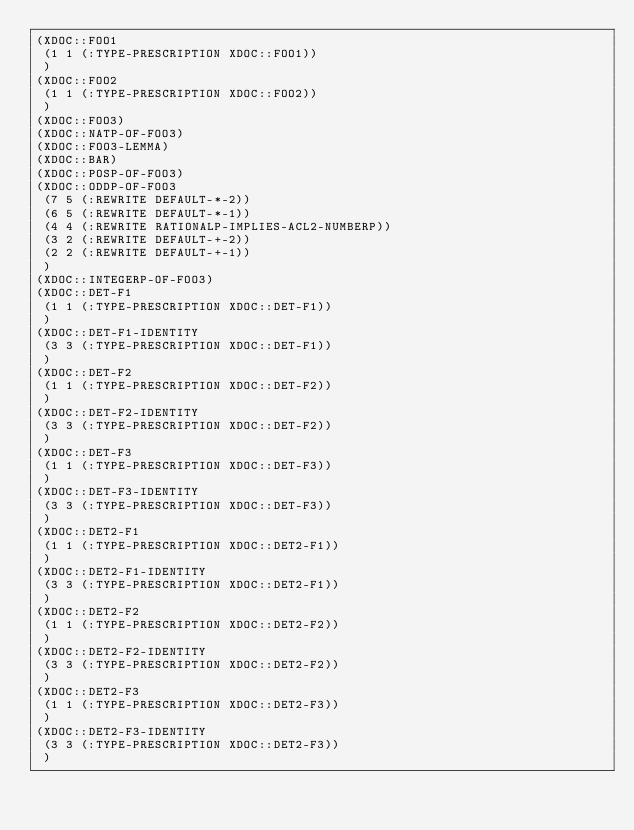<code> <loc_0><loc_0><loc_500><loc_500><_Lisp_>(XDOC::FOO1
 (1 1 (:TYPE-PRESCRIPTION XDOC::FOO1))
 )
(XDOC::FOO2
 (1 1 (:TYPE-PRESCRIPTION XDOC::FOO2))
 )
(XDOC::FOO3)
(XDOC::NATP-OF-FOO3)
(XDOC::FOO3-LEMMA)
(XDOC::BAR)
(XDOC::POSP-OF-FOO3)
(XDOC::ODDP-OF-FOO3
 (7 5 (:REWRITE DEFAULT-*-2))
 (6 5 (:REWRITE DEFAULT-*-1))
 (4 4 (:REWRITE RATIONALP-IMPLIES-ACL2-NUMBERP))
 (3 2 (:REWRITE DEFAULT-+-2))
 (2 2 (:REWRITE DEFAULT-+-1))
 )
(XDOC::INTEGERP-OF-FOO3)
(XDOC::DET-F1
 (1 1 (:TYPE-PRESCRIPTION XDOC::DET-F1))
 )
(XDOC::DET-F1-IDENTITY
 (3 3 (:TYPE-PRESCRIPTION XDOC::DET-F1))
 )
(XDOC::DET-F2
 (1 1 (:TYPE-PRESCRIPTION XDOC::DET-F2))
 )
(XDOC::DET-F2-IDENTITY
 (3 3 (:TYPE-PRESCRIPTION XDOC::DET-F2))
 )
(XDOC::DET-F3
 (1 1 (:TYPE-PRESCRIPTION XDOC::DET-F3))
 )
(XDOC::DET-F3-IDENTITY
 (3 3 (:TYPE-PRESCRIPTION XDOC::DET-F3))
 )
(XDOC::DET2-F1
 (1 1 (:TYPE-PRESCRIPTION XDOC::DET2-F1))
 )
(XDOC::DET2-F1-IDENTITY
 (3 3 (:TYPE-PRESCRIPTION XDOC::DET2-F1))
 )
(XDOC::DET2-F2
 (1 1 (:TYPE-PRESCRIPTION XDOC::DET2-F2))
 )
(XDOC::DET2-F2-IDENTITY
 (3 3 (:TYPE-PRESCRIPTION XDOC::DET2-F2))
 )
(XDOC::DET2-F3
 (1 1 (:TYPE-PRESCRIPTION XDOC::DET2-F3))
 )
(XDOC::DET2-F3-IDENTITY
 (3 3 (:TYPE-PRESCRIPTION XDOC::DET2-F3))
 )
</code> 